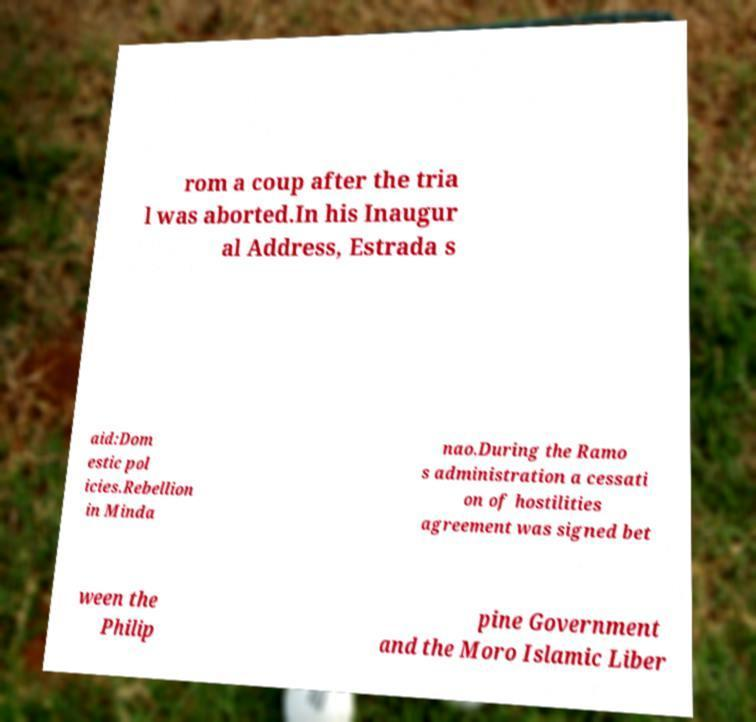Can you accurately transcribe the text from the provided image for me? rom a coup after the tria l was aborted.In his Inaugur al Address, Estrada s aid:Dom estic pol icies.Rebellion in Minda nao.During the Ramo s administration a cessati on of hostilities agreement was signed bet ween the Philip pine Government and the Moro Islamic Liber 